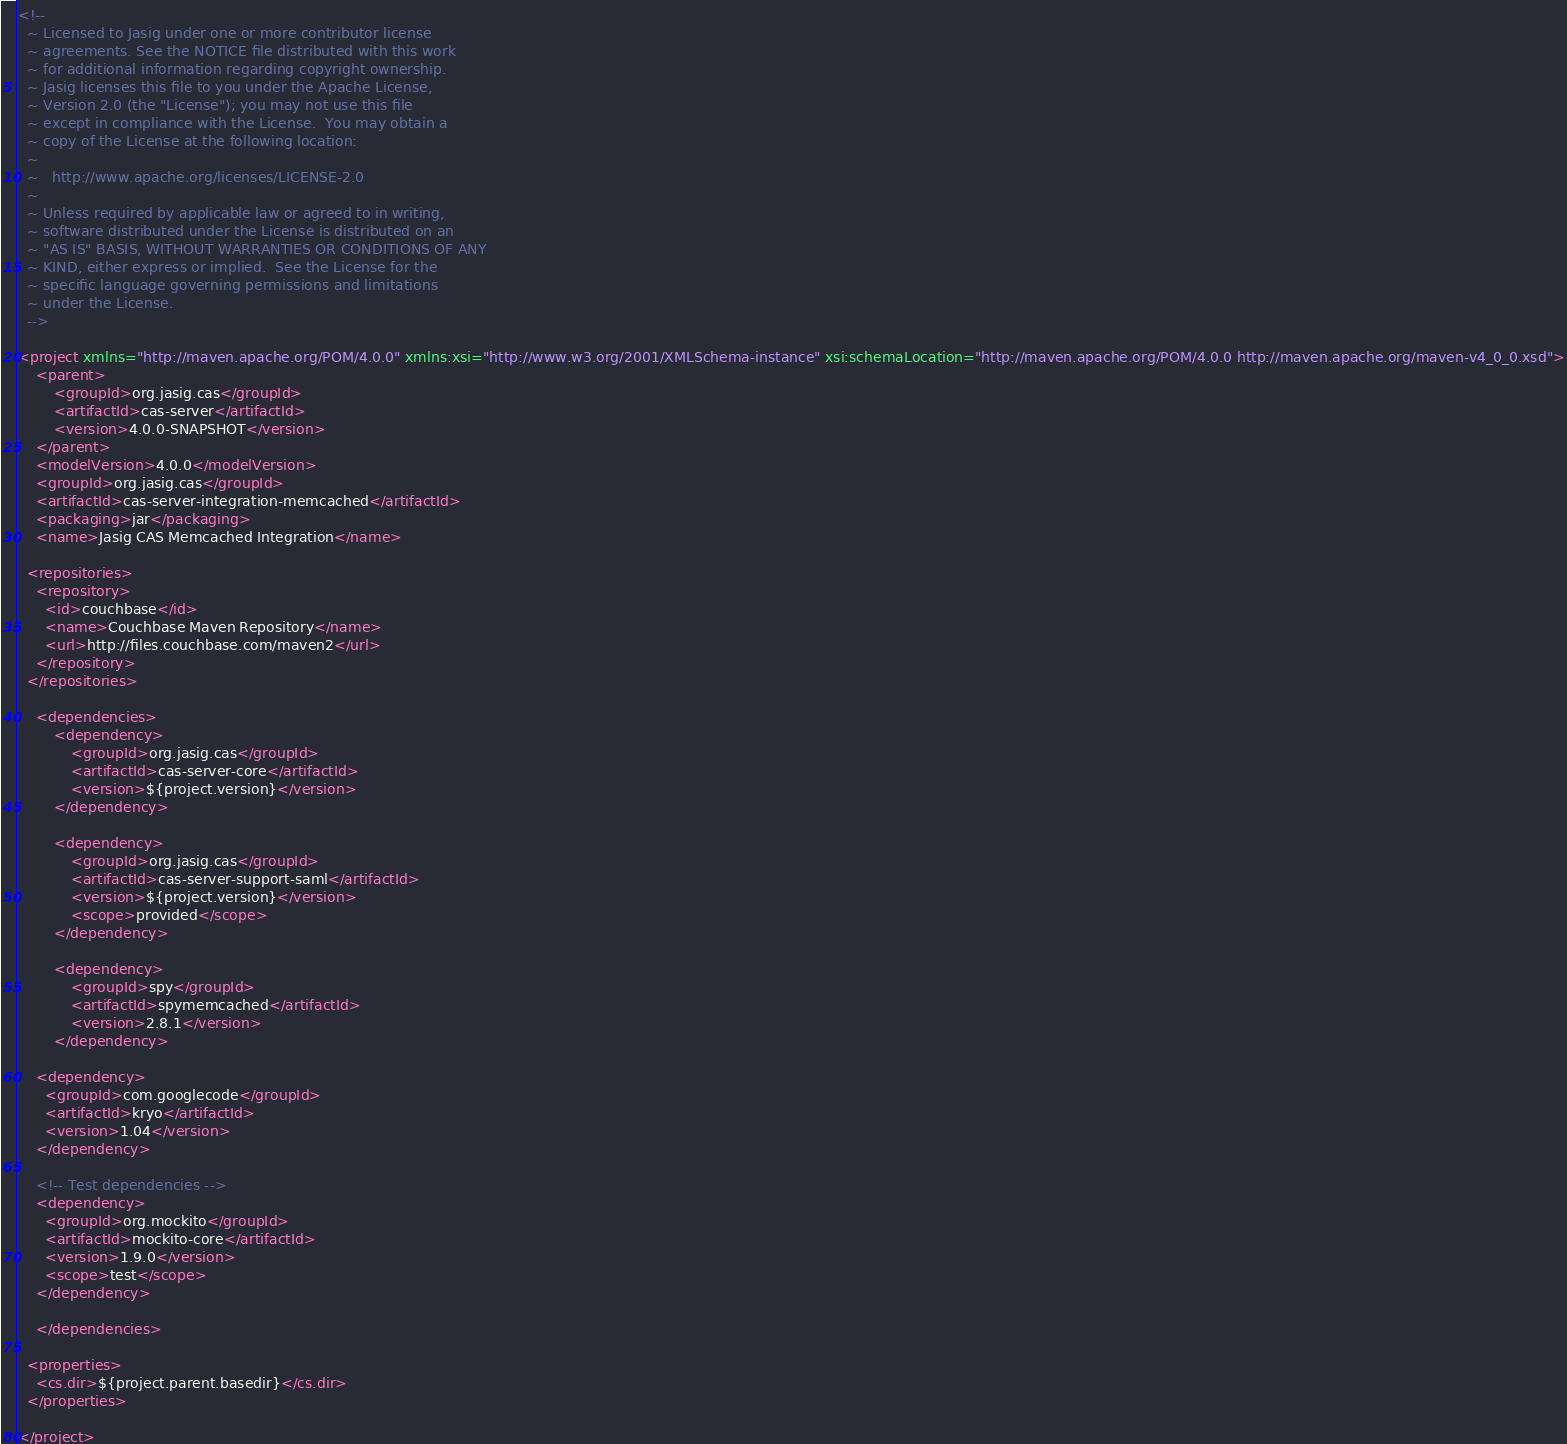<code> <loc_0><loc_0><loc_500><loc_500><_XML_><!--
  ~ Licensed to Jasig under one or more contributor license
  ~ agreements. See the NOTICE file distributed with this work
  ~ for additional information regarding copyright ownership.
  ~ Jasig licenses this file to you under the Apache License,
  ~ Version 2.0 (the "License"); you may not use this file
  ~ except in compliance with the License.  You may obtain a
  ~ copy of the License at the following location:
  ~
  ~   http://www.apache.org/licenses/LICENSE-2.0
  ~
  ~ Unless required by applicable law or agreed to in writing,
  ~ software distributed under the License is distributed on an
  ~ "AS IS" BASIS, WITHOUT WARRANTIES OR CONDITIONS OF ANY
  ~ KIND, either express or implied.  See the License for the
  ~ specific language governing permissions and limitations
  ~ under the License.
  -->

<project xmlns="http://maven.apache.org/POM/4.0.0" xmlns:xsi="http://www.w3.org/2001/XMLSchema-instance" xsi:schemaLocation="http://maven.apache.org/POM/4.0.0 http://maven.apache.org/maven-v4_0_0.xsd">
	<parent>
		<groupId>org.jasig.cas</groupId>
		<artifactId>cas-server</artifactId>
		<version>4.0.0-SNAPSHOT</version>
	</parent>
	<modelVersion>4.0.0</modelVersion>
	<groupId>org.jasig.cas</groupId>
	<artifactId>cas-server-integration-memcached</artifactId>
	<packaging>jar</packaging>
	<name>Jasig CAS Memcached Integration</name>

  <repositories>
    <repository>
      <id>couchbase</id>
      <name>Couchbase Maven Repository</name>
      <url>http://files.couchbase.com/maven2</url>
    </repository>
  </repositories>
	
	<dependencies>
		<dependency>
			<groupId>org.jasig.cas</groupId>
			<artifactId>cas-server-core</artifactId>
			<version>${project.version}</version>
		</dependency>

        <dependency>
            <groupId>org.jasig.cas</groupId>
            <artifactId>cas-server-support-saml</artifactId>
            <version>${project.version}</version>
            <scope>provided</scope>
        </dependency>
		
		<dependency>
			<groupId>spy</groupId>
			<artifactId>spymemcached</artifactId>
			<version>2.8.1</version>
		</dependency>

    <dependency>
      <groupId>com.googlecode</groupId>
      <artifactId>kryo</artifactId>
      <version>1.04</version>
    </dependency>

    <!-- Test dependencies -->
    <dependency>
      <groupId>org.mockito</groupId>
      <artifactId>mockito-core</artifactId>
      <version>1.9.0</version>
      <scope>test</scope>
    </dependency>

	</dependencies>

  <properties>
    <cs.dir>${project.parent.basedir}</cs.dir>
  </properties>

</project>
</code> 